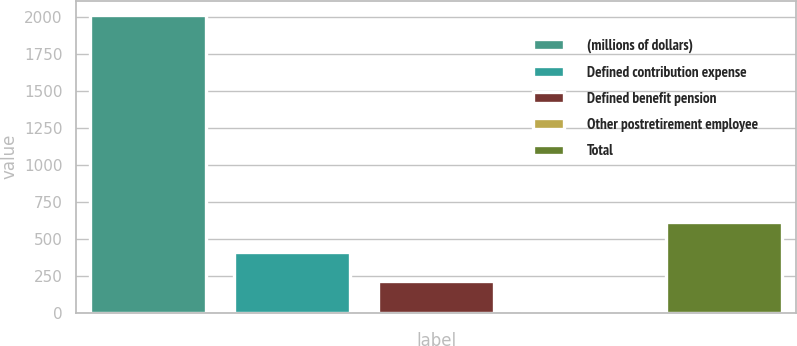Convert chart. <chart><loc_0><loc_0><loc_500><loc_500><bar_chart><fcel>(millions of dollars)<fcel>Defined contribution expense<fcel>Defined benefit pension<fcel>Other postretirement employee<fcel>Total<nl><fcel>2011<fcel>413<fcel>213.25<fcel>13.5<fcel>612.75<nl></chart> 